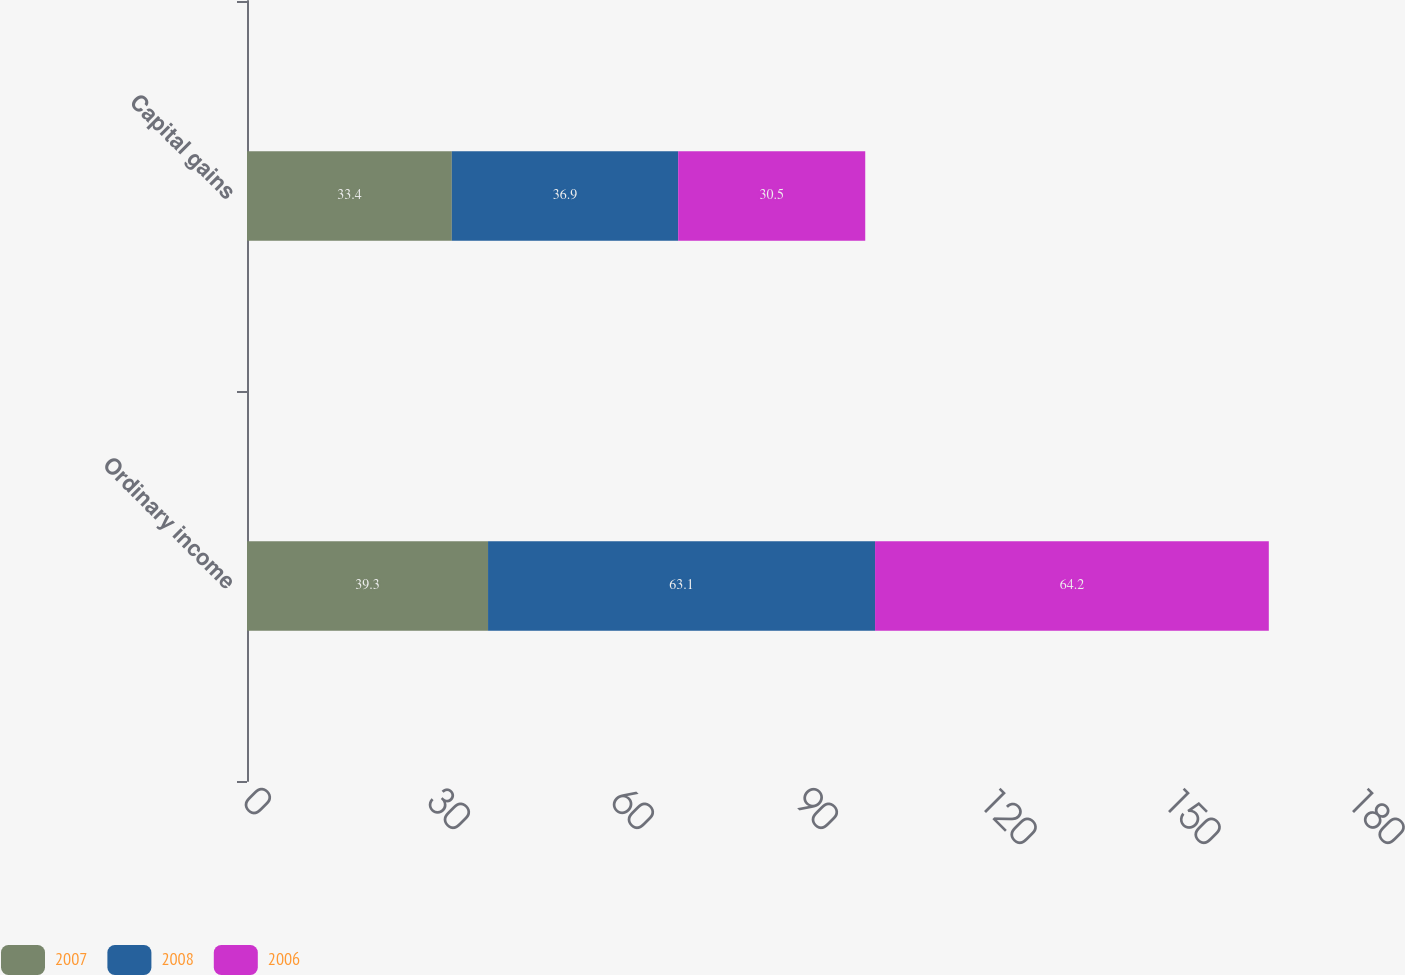Convert chart. <chart><loc_0><loc_0><loc_500><loc_500><stacked_bar_chart><ecel><fcel>Ordinary income<fcel>Capital gains<nl><fcel>2007<fcel>39.3<fcel>33.4<nl><fcel>2008<fcel>63.1<fcel>36.9<nl><fcel>2006<fcel>64.2<fcel>30.5<nl></chart> 